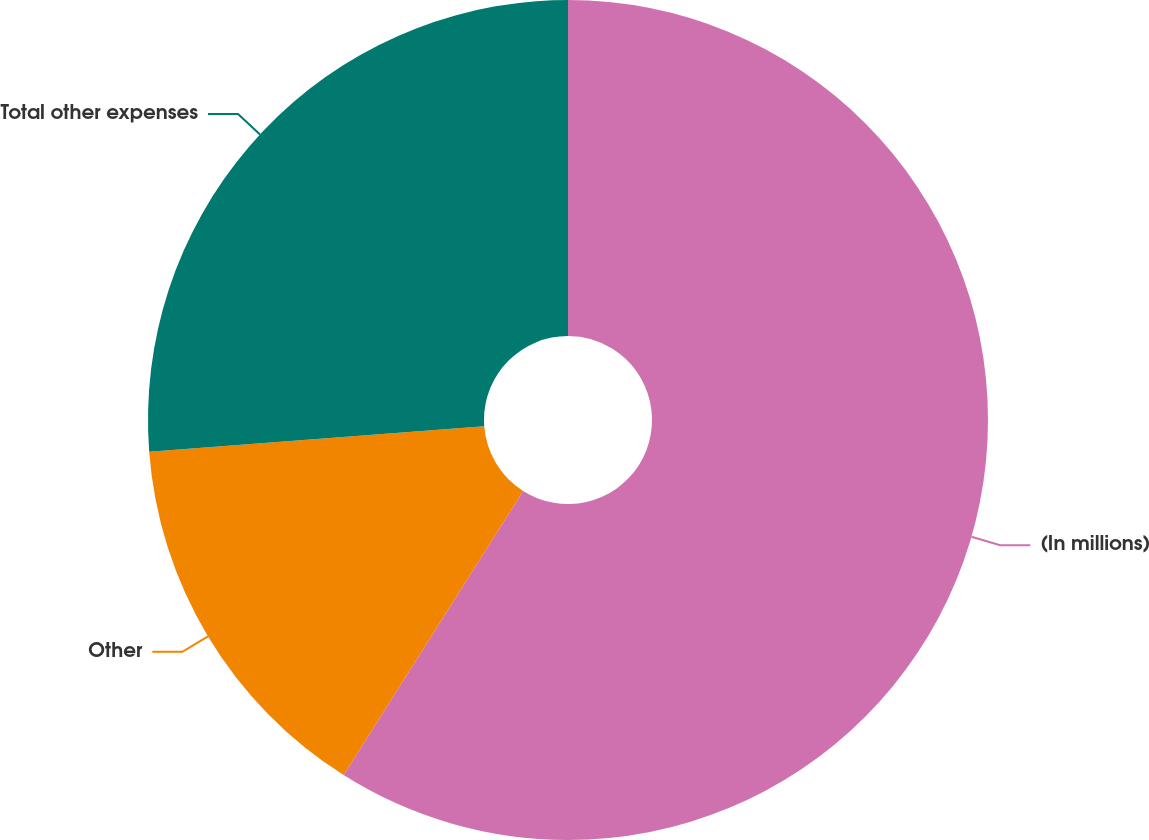Convert chart to OTSL. <chart><loc_0><loc_0><loc_500><loc_500><pie_chart><fcel>(In millions)<fcel>Other<fcel>Total other expenses<nl><fcel>58.97%<fcel>14.83%<fcel>26.2%<nl></chart> 